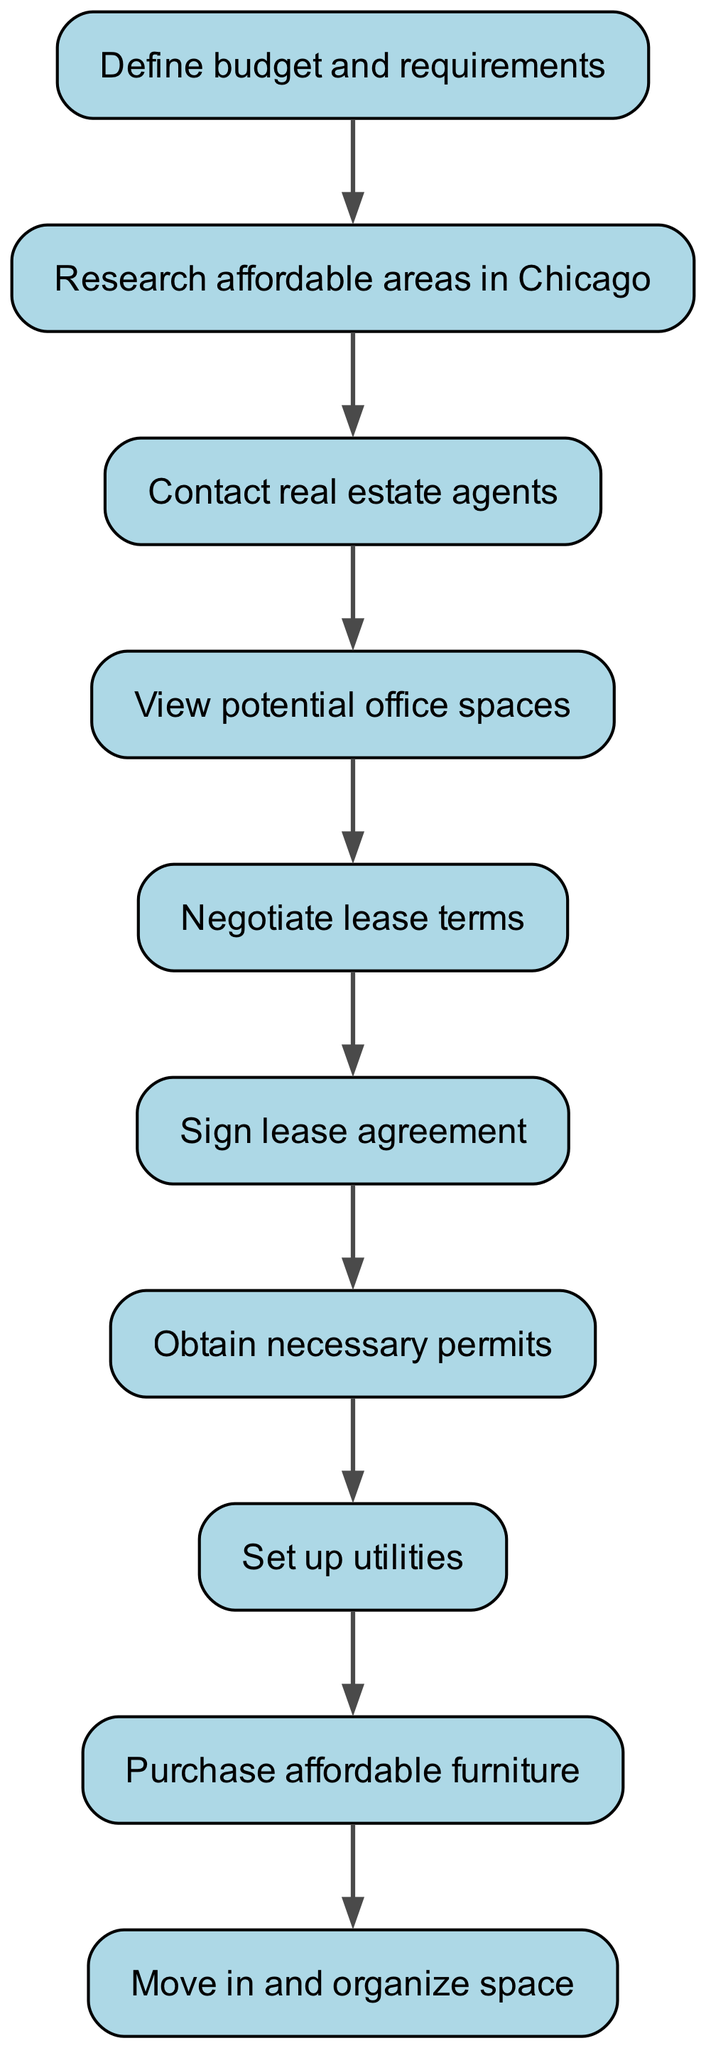What is the first step to take when securing an office space? The first step listed in the flowchart is "Define budget and requirements." This is the initial action to take in the process.
Answer: Define budget and requirements How many nodes are there in the flowchart? The flowchart features ten nodes, each representing a distinct step in the process of securing and setting up a new office space.
Answer: 10 What does the node after "View potential office spaces" represent? After the node "View potential office spaces," the next node is "Negotiate lease terms." This shows the progression from viewing to negotiating.
Answer: Negotiate lease terms Which step comes directly after signing the lease agreement? The step that immediately follows "Sign lease agreement" is "Obtain necessary permits." This indicates the legal requirements following the lease signing.
Answer: Obtain necessary permits What is the relationship between "Research affordable areas in Chicago" and "Contact real estate agents"? In the flowchart, "Research affordable areas in Chicago" leads directly to "Contact real estate agents," indicating that research is necessary before reaching out to agents.
Answer: Directly leads to What series of actions must occur after negotiating lease terms? After "Negotiate lease terms," the flowchart outlines that the next steps are "Sign lease agreement," then "Obtain necessary permits," indicating a sequence of actions following lease negotiation.
Answer: Sign lease agreement, Obtain necessary permits How many edges are present in the diagram? The diagram includes nine edges, each representing a connection or flow from one node to the next in the process of securing an office space.
Answer: 9 What is the final action in the process illustrated by the flowchart? The last action detailed in the flowchart is "Move in and organize space." This indicates the completion of the office setup process.
Answer: Move in and organize space What nodes are involved in setting up utilities? The node "Set up utilities" follows "Obtain necessary permits," indicating that obtaining permits is a prerequisite for setting up utilities.
Answer: Obtain necessary permits, Set up utilities What action directly precedes purchasing affordable furniture? The action that comes just before "Purchase affordable furniture" is "Set up utilities," showing that setting up utilities is a step taken before furnishing the office.
Answer: Set up utilities 